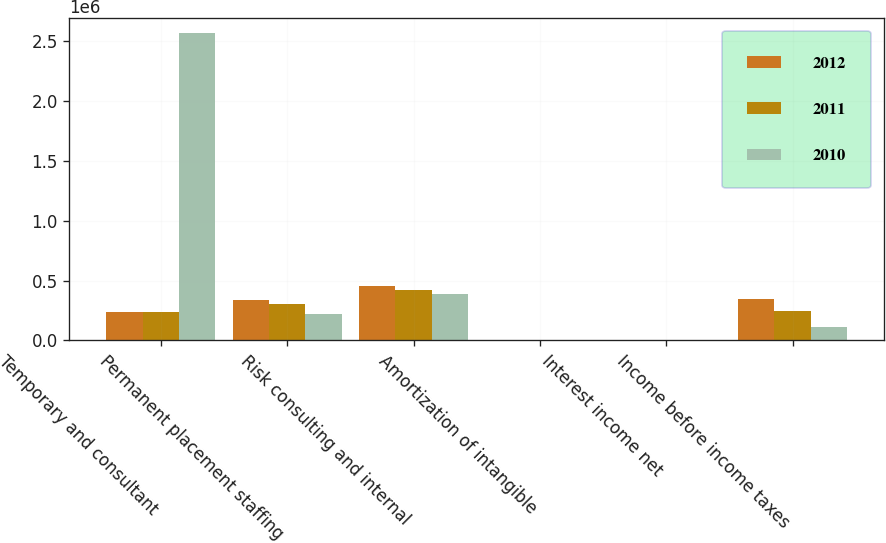Convert chart to OTSL. <chart><loc_0><loc_0><loc_500><loc_500><stacked_bar_chart><ecel><fcel>Temporary and consultant<fcel>Permanent placement staffing<fcel>Risk consulting and internal<fcel>Amortization of intangible<fcel>Interest income net<fcel>Income before income taxes<nl><fcel>2012<fcel>235718<fcel>334198<fcel>452729<fcel>398<fcel>1197<fcel>344245<nl><fcel>2011<fcel>235718<fcel>302155<fcel>423822<fcel>153<fcel>951<fcel>250216<nl><fcel>2010<fcel>2.56826e+06<fcel>221219<fcel>385619<fcel>411<fcel>579<fcel>115168<nl></chart> 